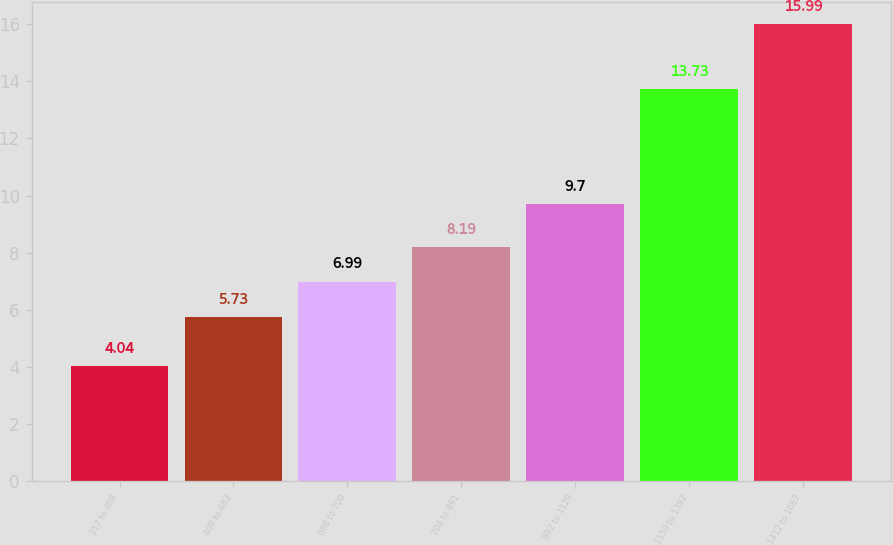Convert chart to OTSL. <chart><loc_0><loc_0><loc_500><loc_500><bar_chart><fcel>317 to 408<fcel>409 to 683<fcel>688 to 700<fcel>704 to 891<fcel>892 to 1129<fcel>1150 to 1392<fcel>1412 to 1667<nl><fcel>4.04<fcel>5.73<fcel>6.99<fcel>8.19<fcel>9.7<fcel>13.73<fcel>15.99<nl></chart> 